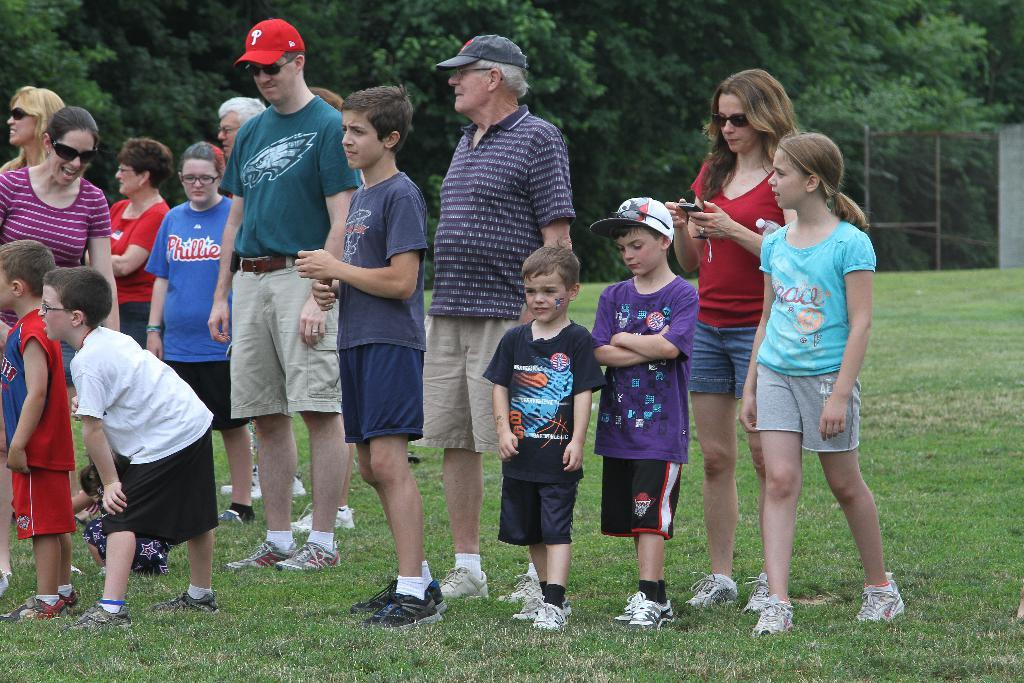How many people are in the group that is visible in the image? There is a group of people standing in the image, but the exact number is not specified. What type of terrain is visible in the image? There is grass in the image, which suggests a natural, outdoor setting. What is the purpose of the fence in the image? The presence of a fence in the image may indicate a boundary or separation between areas. What type of vegetation is visible in the image? There are trees with branches and leaves in the image, which adds to the natural setting. What type of heart can be seen beating in the image? There is no heart visible in the image; it features a group of people standing in a natural setting with grass, a fence, and trees. 